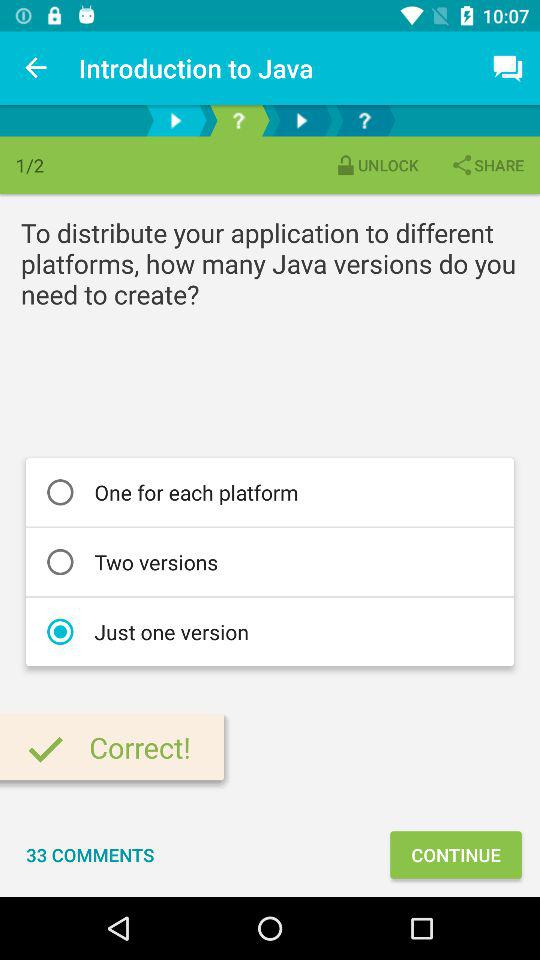What is the selected option? The selected option is "Just one version". 